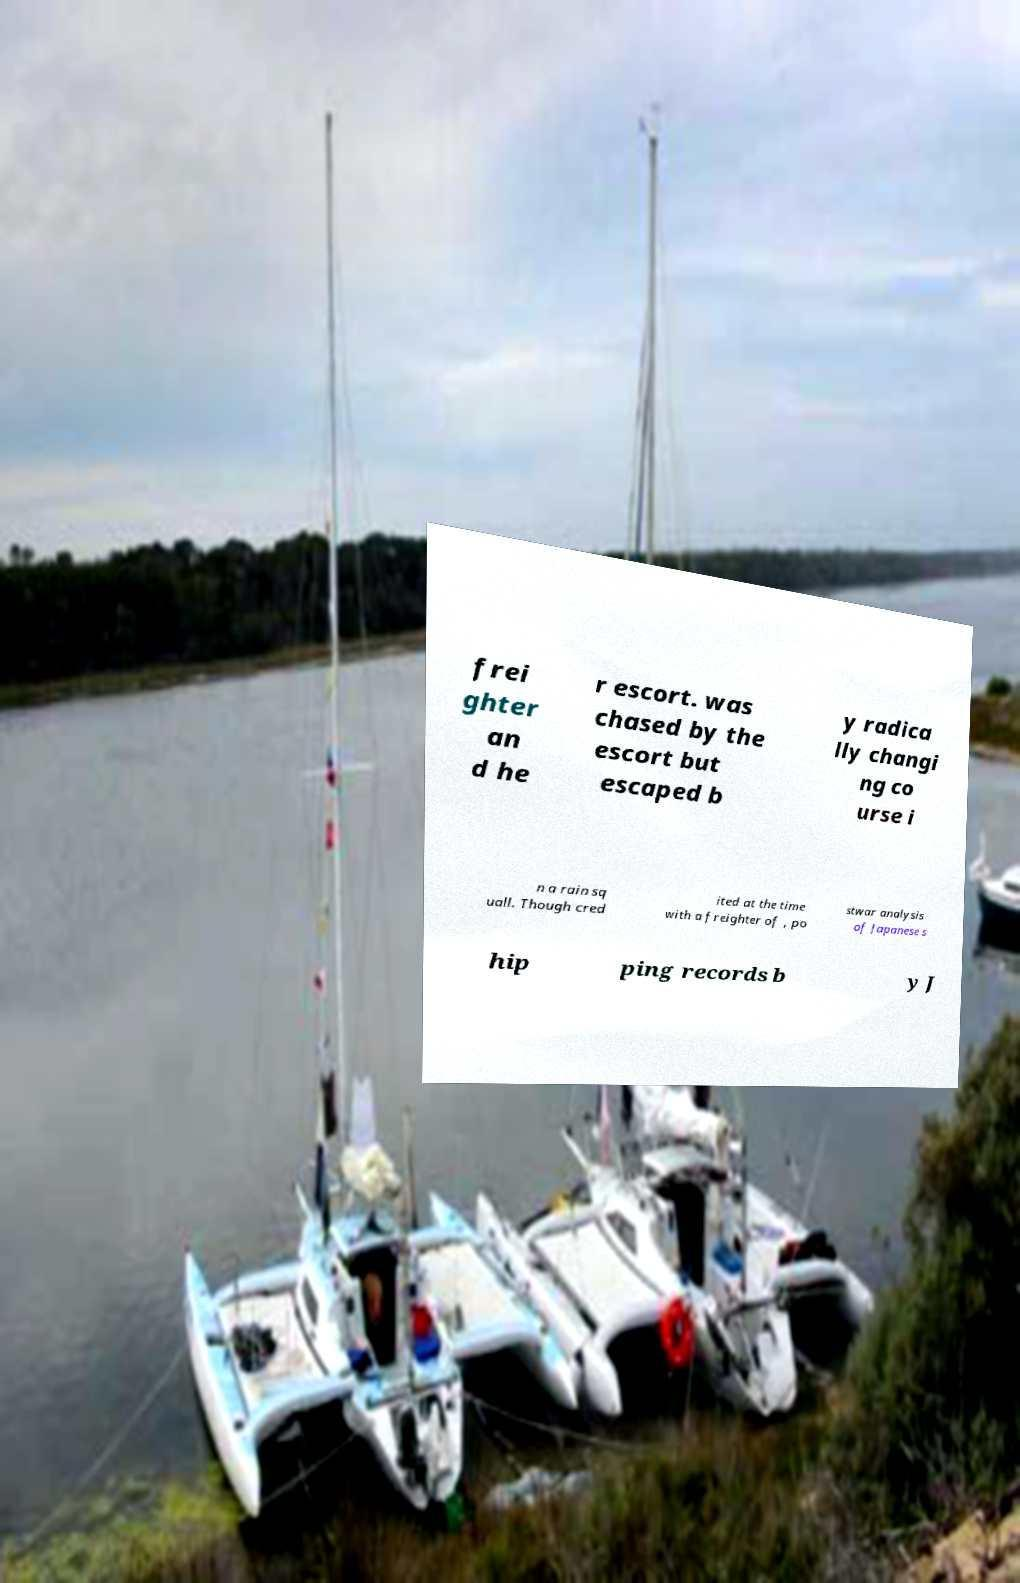Can you read and provide the text displayed in the image?This photo seems to have some interesting text. Can you extract and type it out for me? frei ghter an d he r escort. was chased by the escort but escaped b y radica lly changi ng co urse i n a rain sq uall. Though cred ited at the time with a freighter of , po stwar analysis of Japanese s hip ping records b y J 